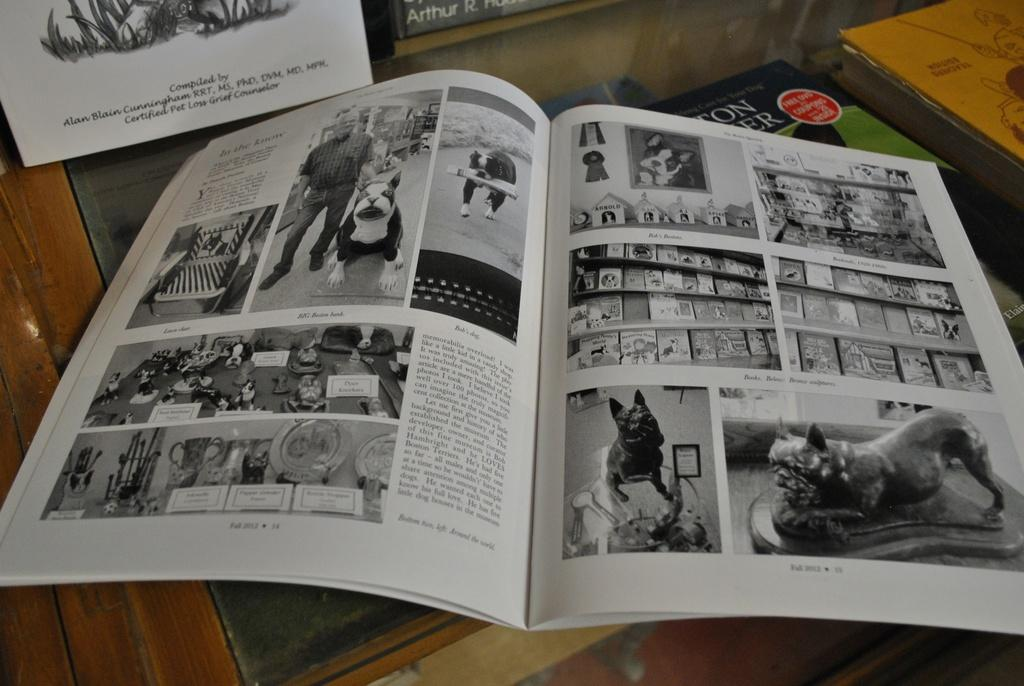<image>
Render a clear and concise summary of the photo. Book showing a page that says 25 on the bottom. 